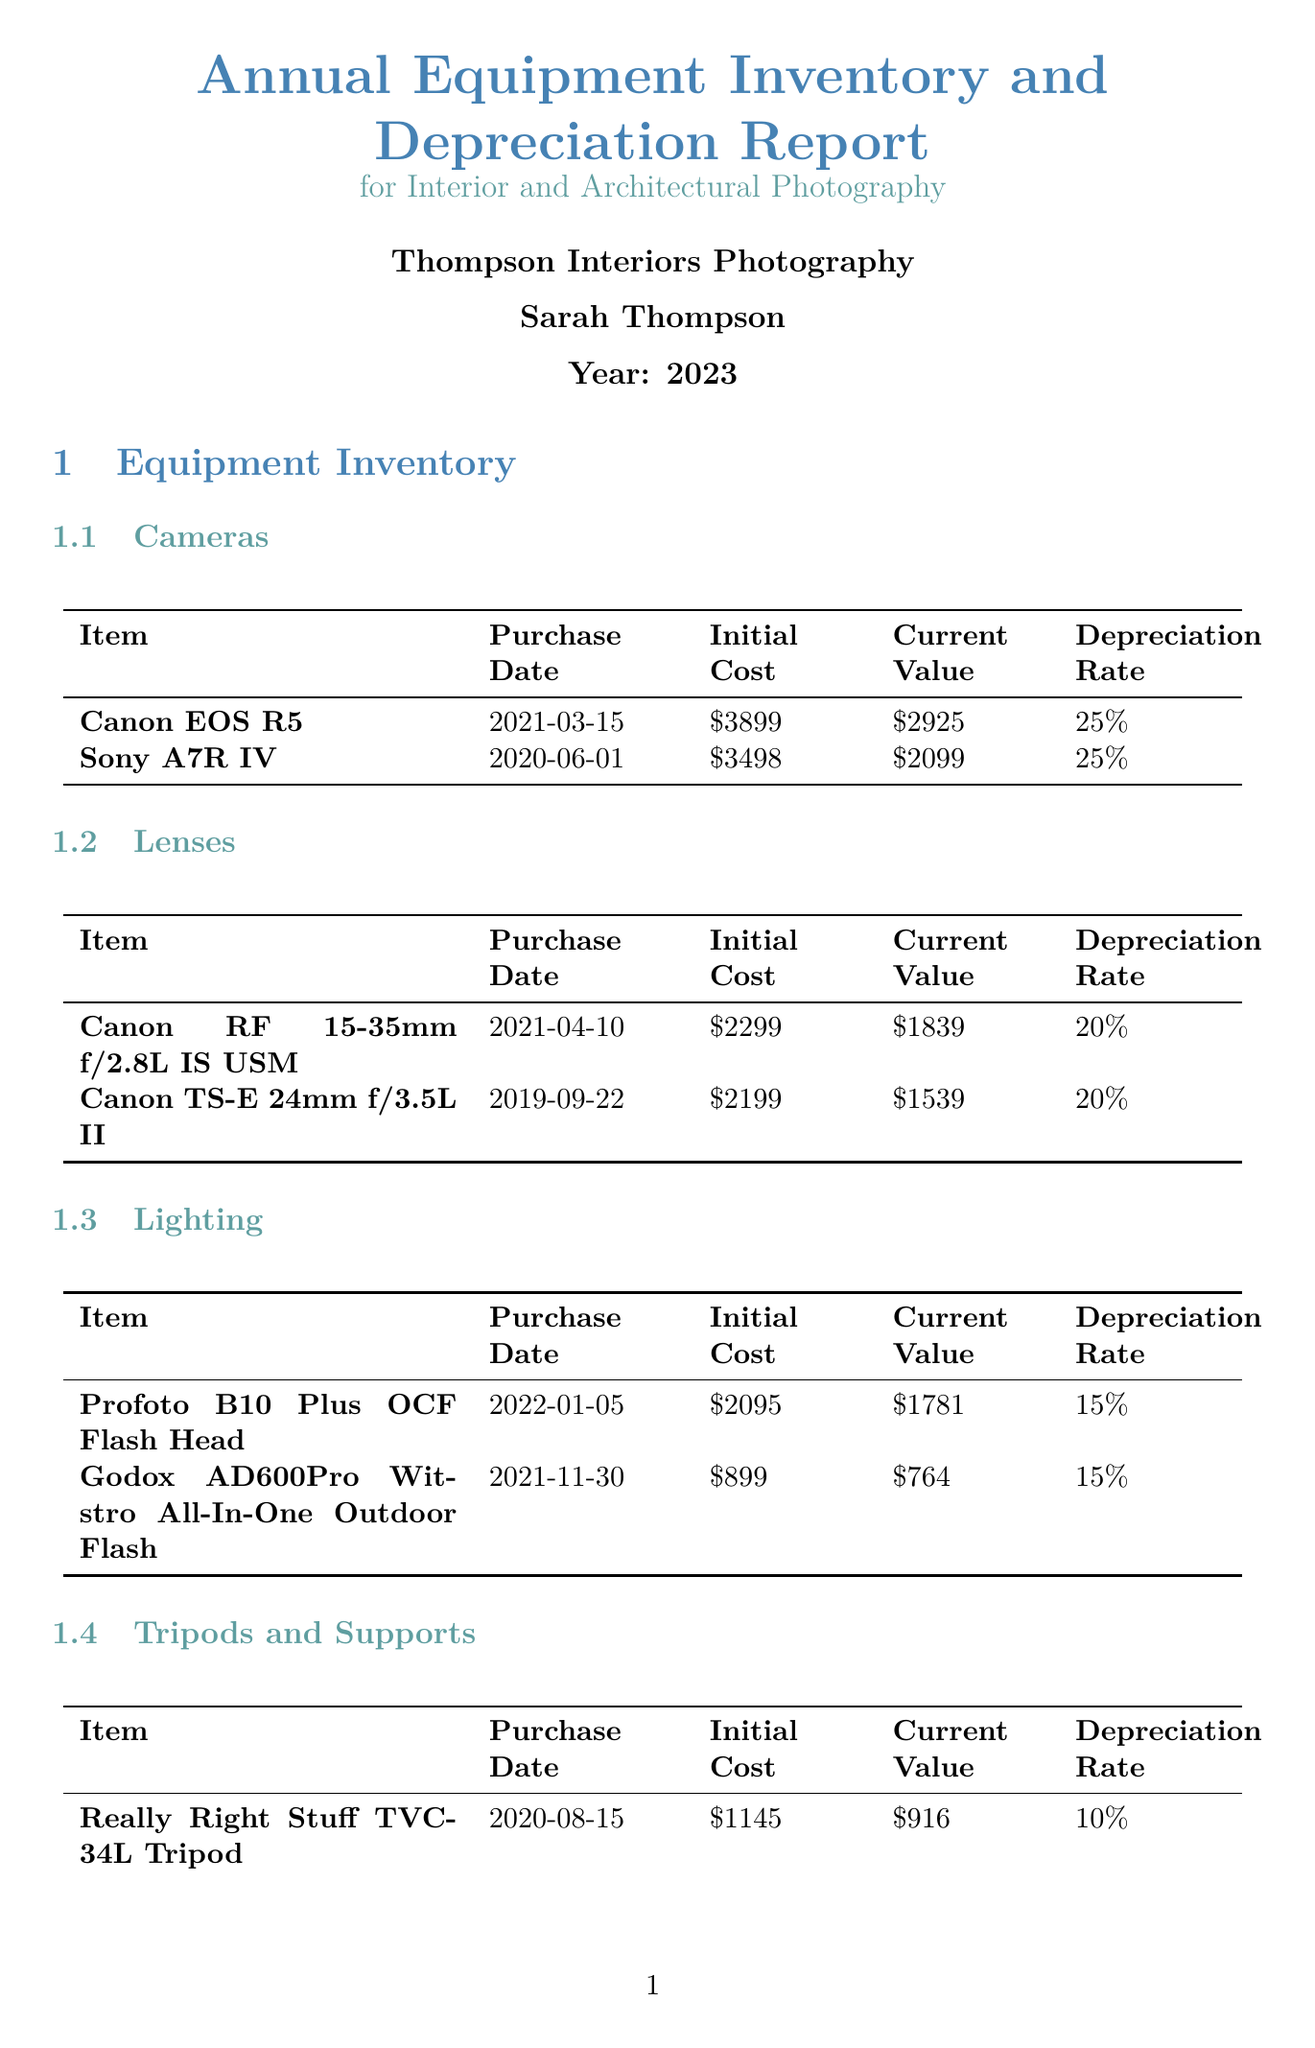what is the initial cost of the Canon EOS R5? The initial cost of the Canon EOS R5 is stated in the document as $3899.
Answer: $3899 what is the current value of the Sony A7R IV? The current value of the Sony A7R IV is found in the equipment section as $2099.
Answer: $2099 what is the total annual depreciation? The total annual depreciation is summarized in the financial section of the document as $3386.60.
Answer: $3386.60 how much does the professional photographer's insurance cost annually? The annual premium for the professional photographer's insurance is listed as $550 in the insurance policies section.
Answer: $550 when was the Canon RF 15-35mm f/2.8L IS USM purchased? The purchase date for the Canon RF 15-35mm f/2.8L IS USM is provided as 2021-04-10 in the lens section.
Answer: 2021-04-10 what is the depreciation rate for tripods and supports? The depreciation rate for tripods and supports is mentioned as 10% in the tripods and supports category.
Answer: 10% what is the recommended drone for investment next year? The document recommends investing in the DJI Mavic 3 drone for aerial interior and exterior shots.
Answer: DJI Mavic 3 what is the coverage limit of the insurance policy? The coverage limit of the professional photographer's insurance policy is stated as $50,000.
Answer: $50,000 how many items are listed under lenses? The document lists a total of two items under lenses in the equipment inventory section.
Answer: 2 